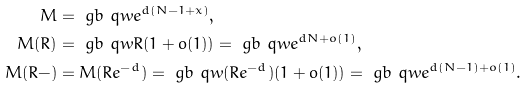Convert formula to latex. <formula><loc_0><loc_0><loc_500><loc_500>M & = \ g b \ q w e ^ { d ( N - 1 + x ) } , \\ M ( R ) & = \ g b \ q w R ( 1 + o ( 1 ) ) = \ g b \ q w e ^ { d N + o ( 1 ) } , \\ M ( R - ) & = M ( R e ^ { - d } ) = \ g b \ q w ( R e ^ { - d } ) ( 1 + o ( 1 ) ) = \ g b \ q w e ^ { d ( N - 1 ) + o ( 1 ) } .</formula> 